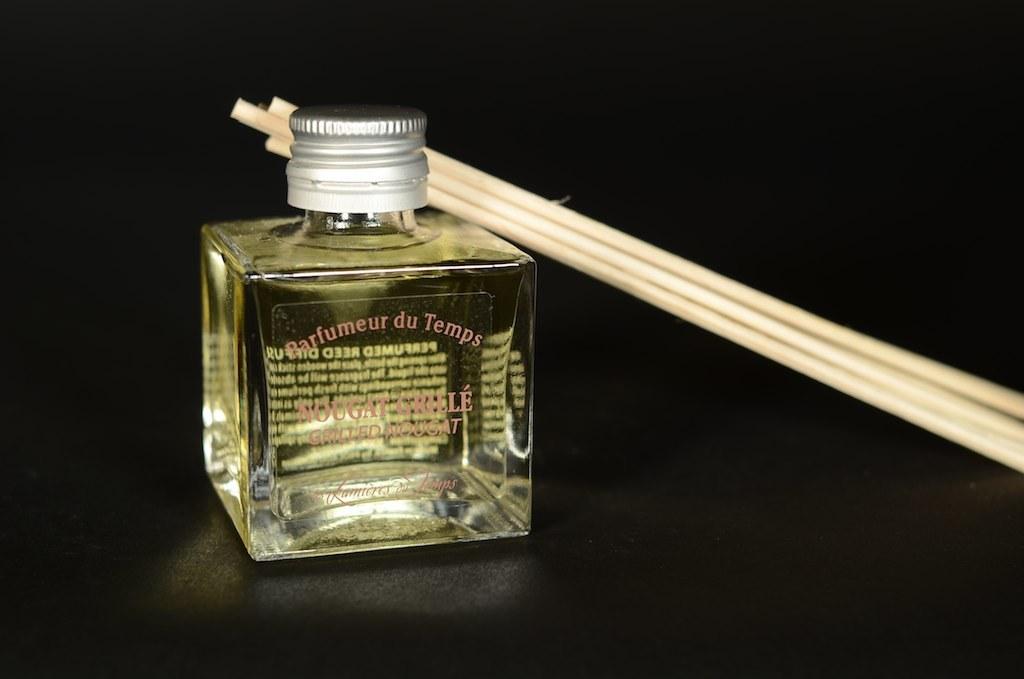What is the name of the fragrance?
Offer a terse response. Parfumeur du temps. 